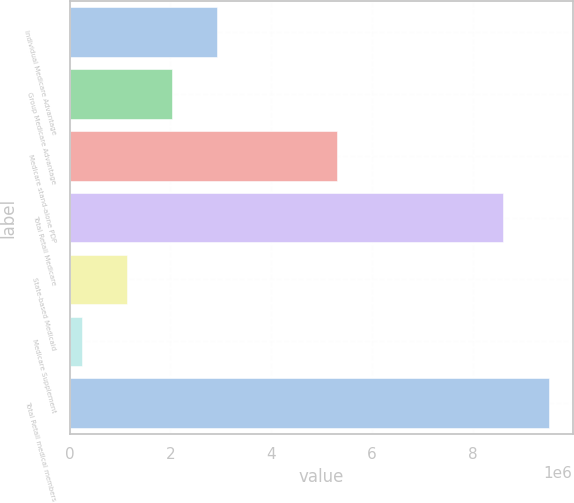Convert chart. <chart><loc_0><loc_0><loc_500><loc_500><bar_chart><fcel>Individual Medicare Advantage<fcel>Group Medicare Advantage<fcel>Medicare stand-alone PDP<fcel>Total Retail Medicare<fcel>State-based Medicaid<fcel>Medicare Supplement<fcel>Total Retail medical members<nl><fcel>2.92702e+06<fcel>2.02998e+06<fcel>5.3081e+06<fcel>8.6103e+06<fcel>1.13294e+06<fcel>235900<fcel>9.50734e+06<nl></chart> 